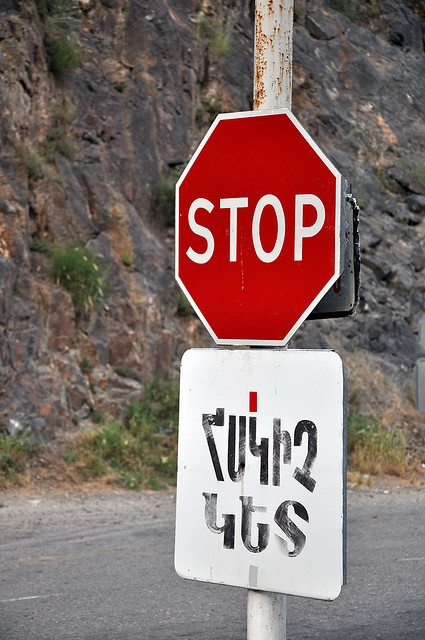Describe the objects in this image and their specific colors. I can see a stop sign in black, brown, white, and gray tones in this image. 